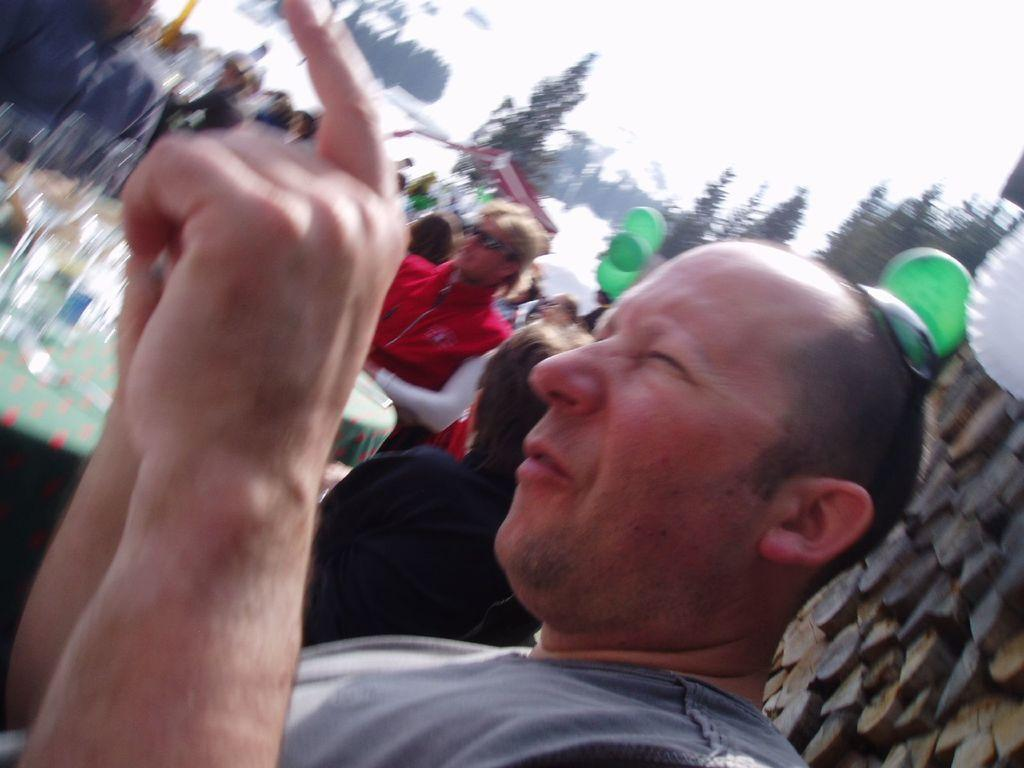What can be seen in the image related to people? There are many people wearing clothes in the image. What else is present in the image besides people? There are balloons and trees in the image. What is visible in the background of the image? The sky is visible in the image. How is the background of the image depicted? The background of the image is blurred. What type of lace is being used to decorate the baby's crib in the image? There is no baby or crib present in the image, so it is not possible to answer that question. 